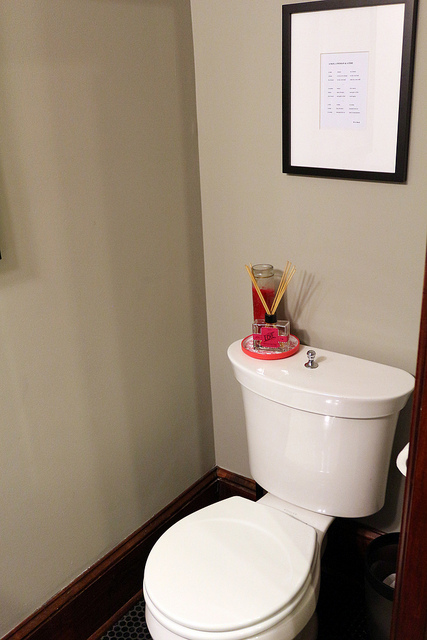Is there anything that indicates the possible location or setting of this bathroom? While the specific location isn't indicated, the design and items indicate a private or residential setting rather than a public one. The framed document on the wall might provide some clue, but it is not clearly readable from this angle. 